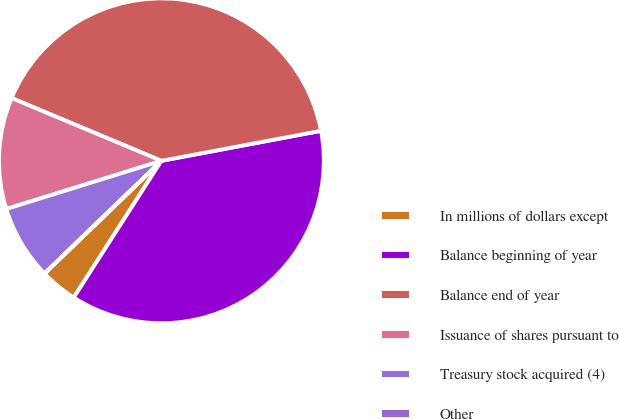Convert chart. <chart><loc_0><loc_0><loc_500><loc_500><pie_chart><fcel>In millions of dollars except<fcel>Balance beginning of year<fcel>Balance end of year<fcel>Issuance of shares pursuant to<fcel>Treasury stock acquired (4)<fcel>Other<nl><fcel>3.71%<fcel>37.03%<fcel>40.73%<fcel>11.11%<fcel>7.41%<fcel>0.01%<nl></chart> 